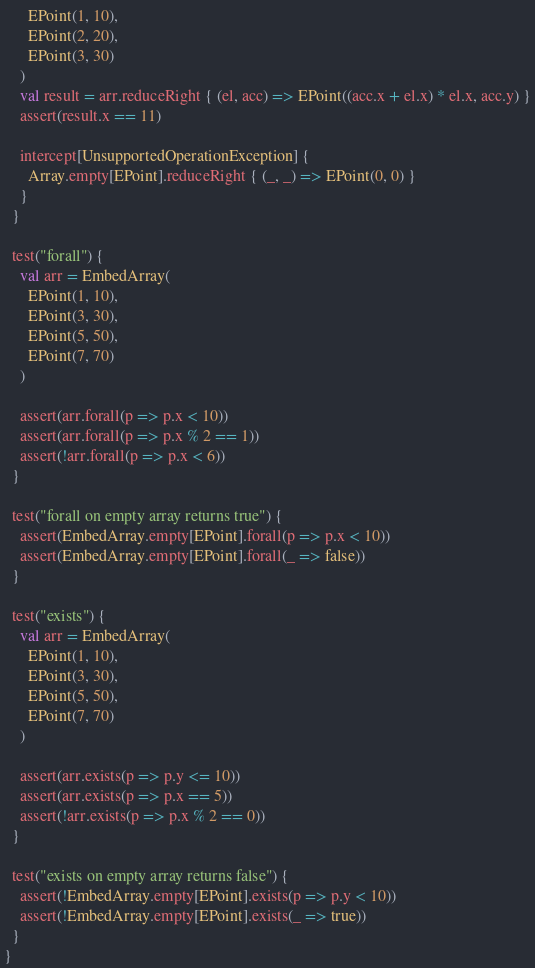Convert code to text. <code><loc_0><loc_0><loc_500><loc_500><_Scala_>      EPoint(1, 10),
      EPoint(2, 20),
      EPoint(3, 30)
    )
    val result = arr.reduceRight { (el, acc) => EPoint((acc.x + el.x) * el.x, acc.y) }
    assert(result.x == 11)

    intercept[UnsupportedOperationException] {
      Array.empty[EPoint].reduceRight { (_, _) => EPoint(0, 0) }
    }
  }

  test("forall") {
    val arr = EmbedArray(
      EPoint(1, 10),
      EPoint(3, 30),
      EPoint(5, 50),
      EPoint(7, 70)
    )

    assert(arr.forall(p => p.x < 10))
    assert(arr.forall(p => p.x % 2 == 1))
    assert(!arr.forall(p => p.x < 6))
  }

  test("forall on empty array returns true") {
    assert(EmbedArray.empty[EPoint].forall(p => p.x < 10))
    assert(EmbedArray.empty[EPoint].forall(_ => false))
  }

  test("exists") {
    val arr = EmbedArray(
      EPoint(1, 10),
      EPoint(3, 30),
      EPoint(5, 50),
      EPoint(7, 70)
    )

    assert(arr.exists(p => p.y <= 10))
    assert(arr.exists(p => p.x == 5))
    assert(!arr.exists(p => p.x % 2 == 0))
  }

  test("exists on empty array returns false") {
    assert(!EmbedArray.empty[EPoint].exists(p => p.y < 10))
    assert(!EmbedArray.empty[EPoint].exists(_ => true))
  }
}
</code> 